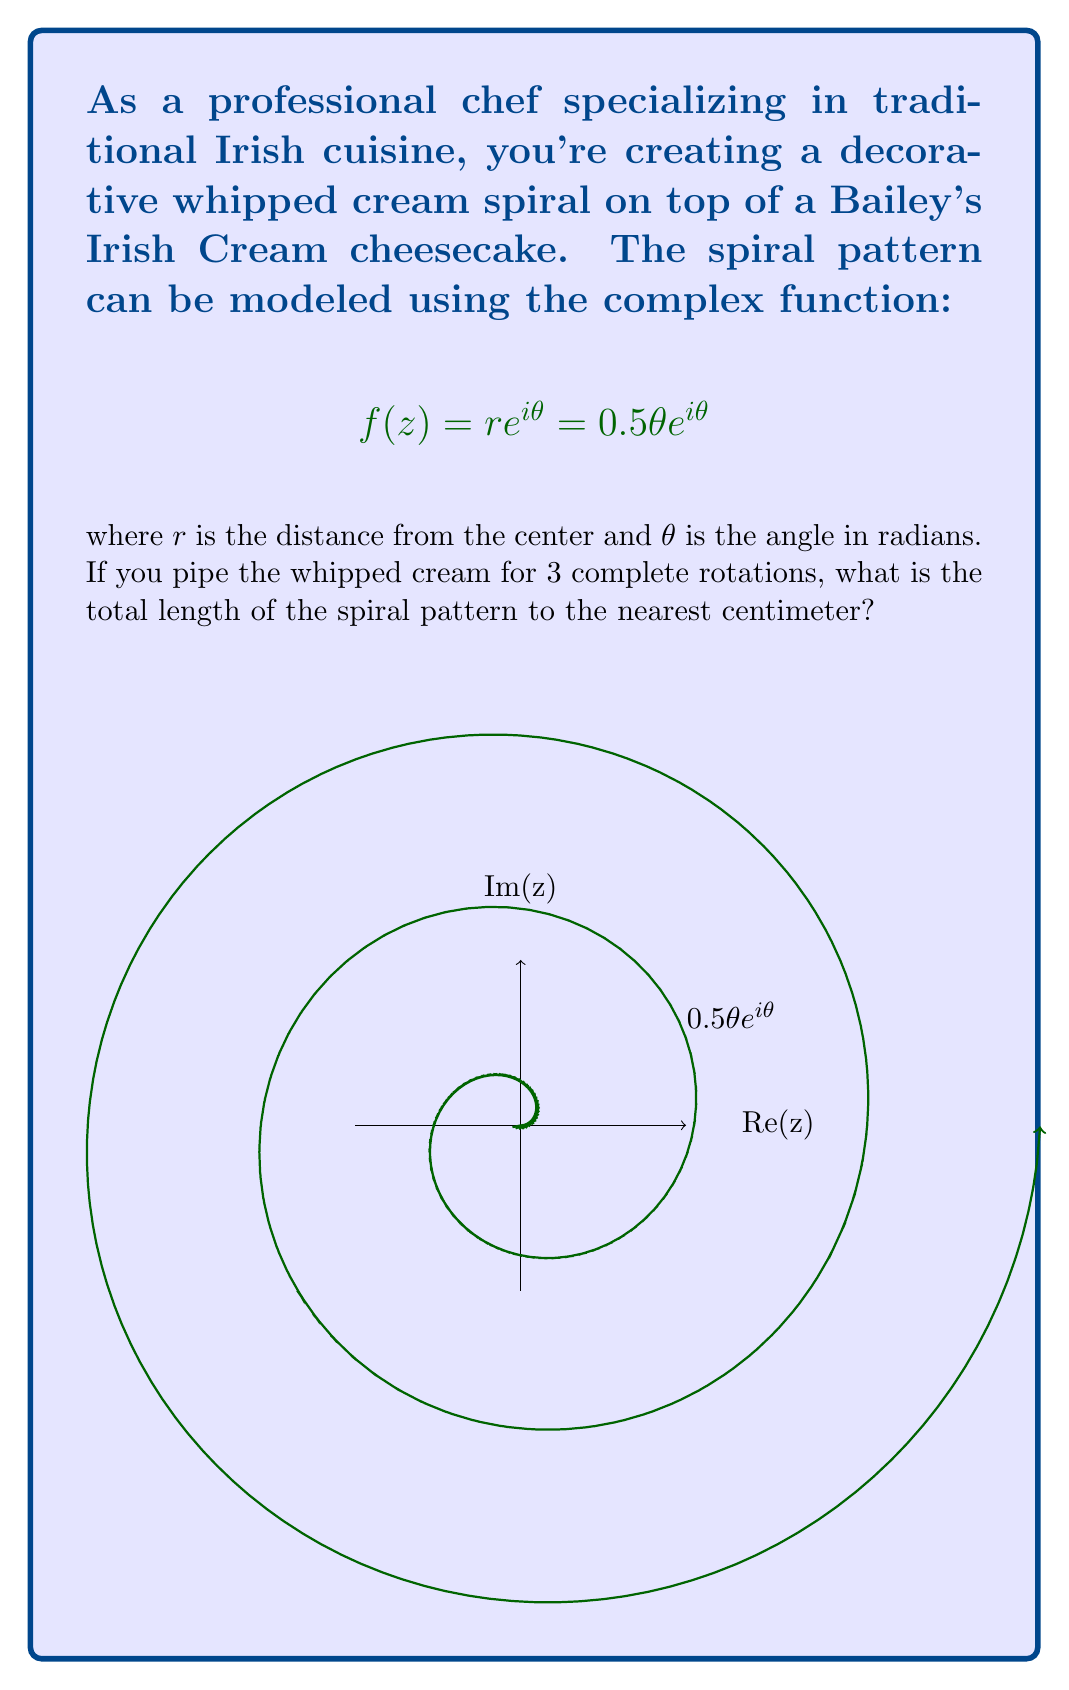Could you help me with this problem? Let's approach this step-by-step:

1) The complex function given is $f(z) = 0.5\theta e^{i\theta}$. This is in polar form where $r = 0.5\theta$ and the angle is $\theta$.

2) To find the length of the spiral, we need to use the arc length formula in polar coordinates:

   $$L = \int_a^b \sqrt{r^2 + \left(\frac{dr}{d\theta}\right)^2} d\theta$$

3) In our case, $r = 0.5\theta$, so $\frac{dr}{d\theta} = 0.5$

4) Substituting these into the formula:

   $$L = \int_0^{6\pi} \sqrt{(0.5\theta)^2 + (0.5)^2} d\theta$$

5) Simplifying under the square root:

   $$L = \int_0^{6\pi} \sqrt{0.25\theta^2 + 0.25} d\theta = 0.5\int_0^{6\pi} \sqrt{\theta^2 + 1} d\theta$$

6) This integral doesn't have an elementary antiderivative. We need to use numerical integration or a special function. The exact result involves the hyperbolic sine function:

   $$L = 0.5[\theta\sqrt{\theta^2+1} + \sinh^{-1}(\theta)]_0^{6\pi}$$

7) Evaluating this at the limits:

   $$L = 0.5[(6\pi\sqrt{36\pi^2+1} + \sinh^{-1}(6\pi)) - (0\sqrt{0^2+1} + \sinh^{-1}(0))]$$

8) Calculating this numerically:

   $$L \approx 29.6791 \text{ cm}$$
Answer: 30 cm 